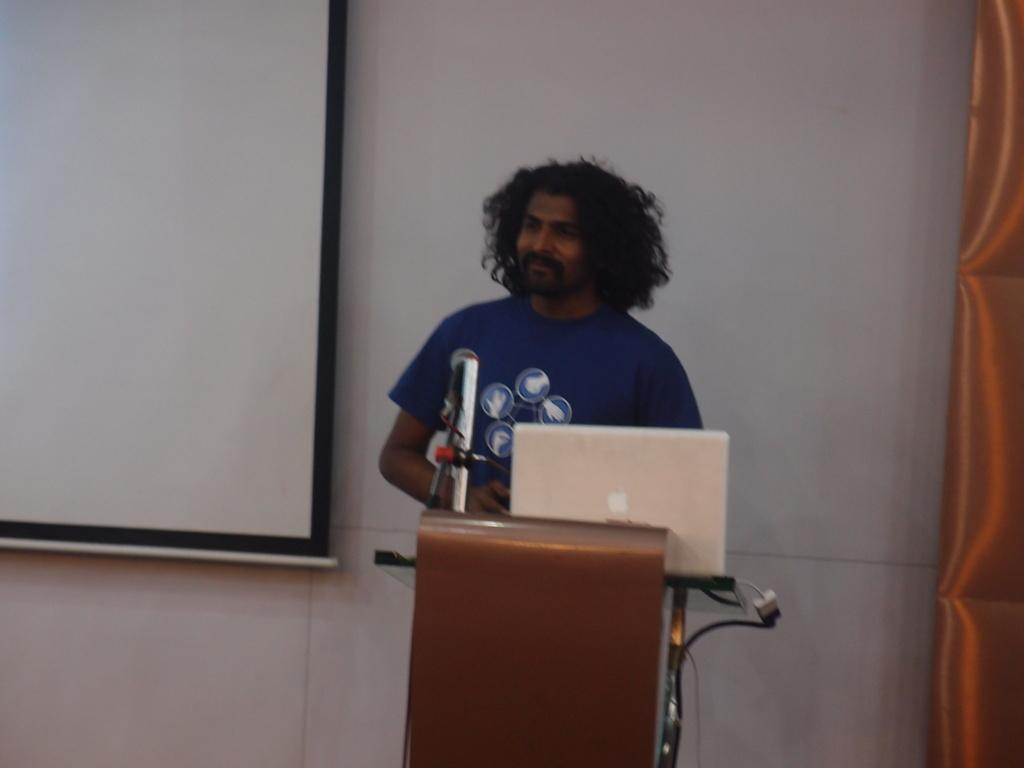What is the man in the image doing? The man is standing in front of a microphone. What object is present near the man? There is a podium in the image. What electronic device can be seen in the image? There is a laptop in the image. What can be seen in the background of the image? There is a wall and a screen in the background of the image. Can you tell me how many horses are present in the image? There are no horses present in the image. What idea does the man have while standing in front of the microphone? The image does not provide any information about the man's ideas or thoughts. 